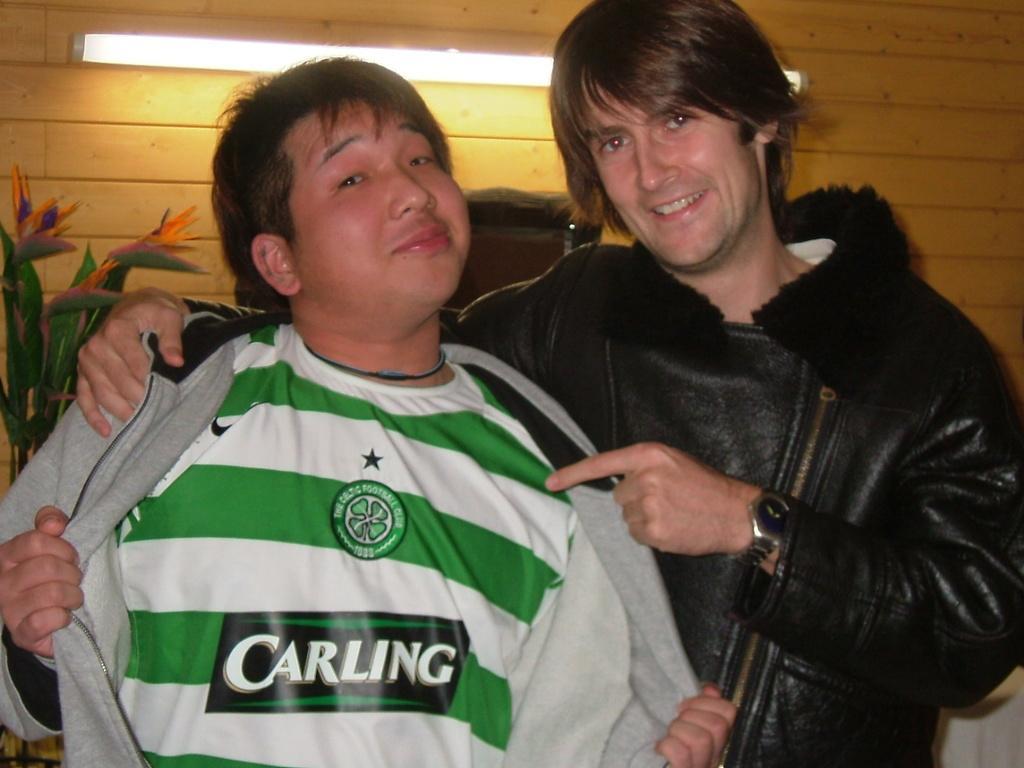Describe this image in one or two sentences. In this image there are two men standing, there is a plant towards the left of the image, there is a light, at the background of the image there is a wall. 